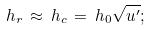Convert formula to latex. <formula><loc_0><loc_0><loc_500><loc_500>h _ { r } \, \approx \, h _ { c } \, = \, h _ { 0 } \sqrt { u ^ { \prime } } ;</formula> 